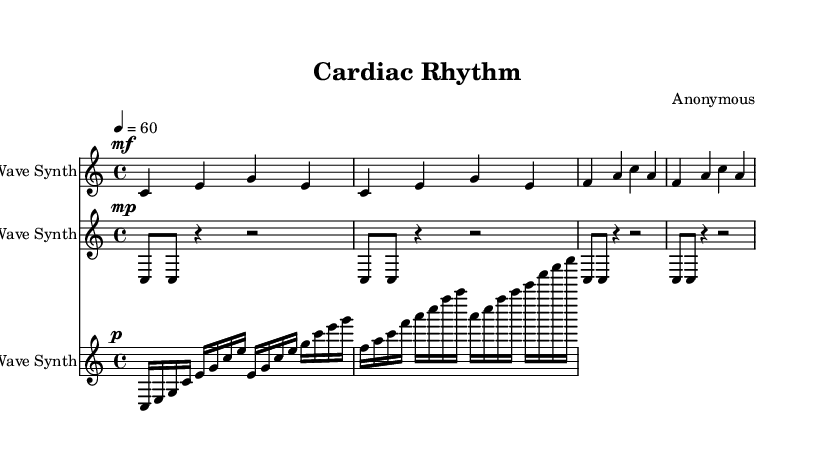What is the key signature of this music? The key signature is C major, which has no sharps or flats.
Answer: C major What is the time signature of this music? The time signature is defined at the beginning of the sheet music as 4/4, indicating four beats per measure.
Answer: 4/4 What is the tempo marking of this composition? The tempo marking at the beginning specifies a speed of 60 beats per minute, indicated by "4 = 60".
Answer: 60 How many measures are in the main melody section? The main melody section contains four measures, as indicated by the groupings of notes within the brackets.
Answer: 4 What instruments are used in this composition? The sheet music specifies three types of synthesizers for the different parts: Sine Wave Synth, Square Wave Synth, and Sawtooth Wave Synth.
Answer: Sine Wave Synth, Square Wave Synth, Sawtooth Wave Synth What rhythmic pattern does the heartbeat rhythm follow? The heartbeat rhythm is characterized by a repeated pattern of two eighth notes followed by a quarter and a half rest, illustrating a pulse-like effect.
Answer: Eighth notes and rests How does the blood flow texture differ from the main melody? The blood flow texture features a more complex rhythm with sixteenth notes and variations in pitch, contrasting with the straightforward quarter notes of the main melody.
Answer: More complex rhythm 